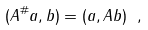<formula> <loc_0><loc_0><loc_500><loc_500>( A ^ { \# } a , b ) = ( a , A b ) \ ,</formula> 